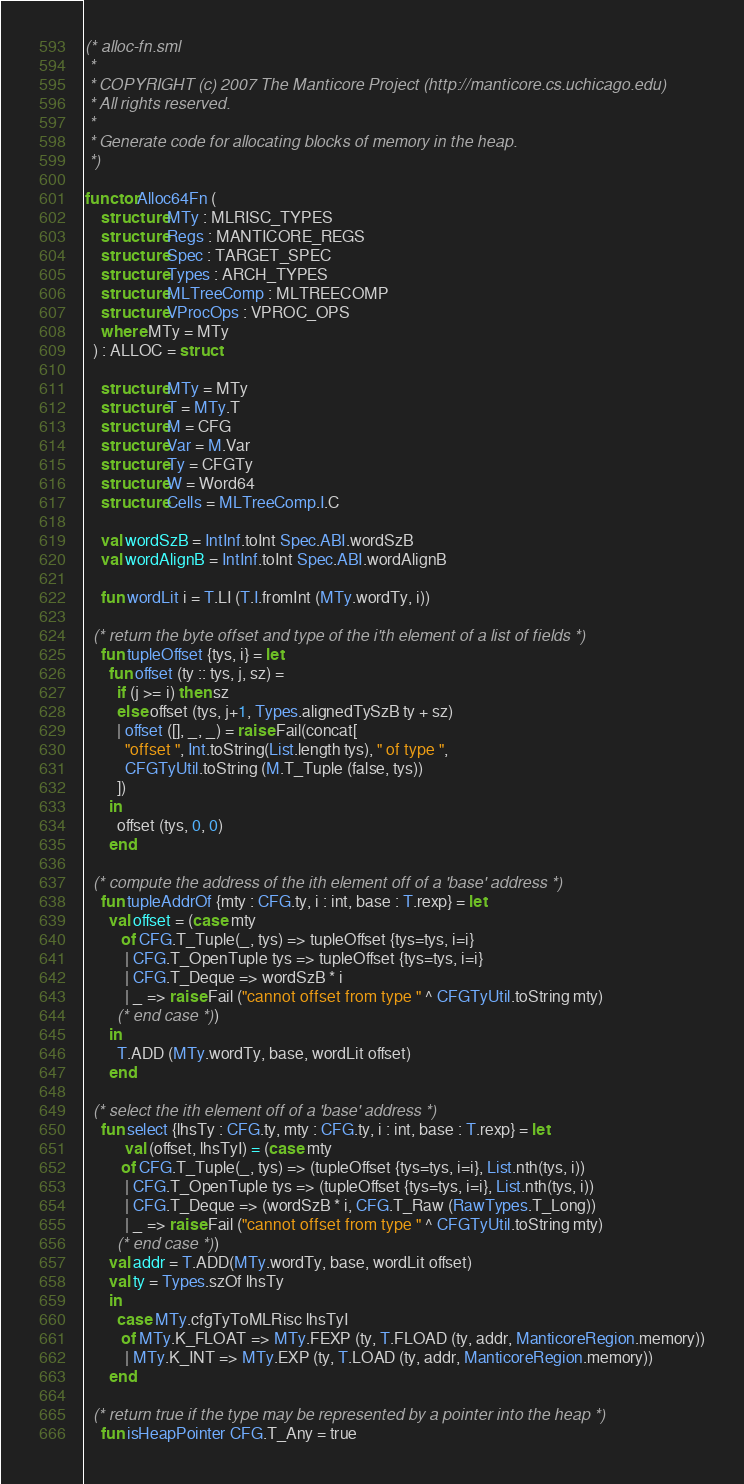<code> <loc_0><loc_0><loc_500><loc_500><_SML_>(* alloc-fn.sml
 *
 * COPYRIGHT (c) 2007 The Manticore Project (http://manticore.cs.uchicago.edu)
 * All rights reserved.
 *
 * Generate code for allocating blocks of memory in the heap.
 *)

functor Alloc64Fn (
    structure MTy : MLRISC_TYPES
    structure Regs : MANTICORE_REGS
    structure Spec : TARGET_SPEC
    structure Types : ARCH_TYPES
    structure MLTreeComp : MLTREECOMP
    structure VProcOps : VPROC_OPS
	where MTy = MTy
  ) : ALLOC = struct

    structure MTy = MTy
    structure T = MTy.T
    structure M = CFG
    structure Var = M.Var
    structure Ty = CFGTy
    structure W = Word64
    structure Cells = MLTreeComp.I.C

    val wordSzB = IntInf.toInt Spec.ABI.wordSzB
    val wordAlignB = IntInf.toInt Spec.ABI.wordAlignB

    fun wordLit i = T.LI (T.I.fromInt (MTy.wordTy, i))

  (* return the byte offset and type of the i'th element of a list of fields *)
    fun tupleOffset {tys, i} = let
	  fun offset (ty :: tys, j, sz) =
		if (j >= i) then sz
		else offset (tys, j+1, Types.alignedTySzB ty + sz)
	    | offset ([], _, _) = raise Fail(concat[
		  "offset ", Int.toString(List.length tys), " of type ",
		  CFGTyUtil.toString (M.T_Tuple (false, tys))
		])
	  in
	    offset (tys, 0, 0)
	  end

  (* compute the address of the ith element off of a 'base' address *)
    fun tupleAddrOf {mty : CFG.ty, i : int, base : T.rexp} = let
	  val offset = (case mty
		 of CFG.T_Tuple(_, tys) => tupleOffset {tys=tys, i=i}
		  | CFG.T_OpenTuple tys => tupleOffset {tys=tys, i=i}
		  | CFG.T_Deque => wordSzB * i
		  | _ => raise Fail ("cannot offset from type " ^ CFGTyUtil.toString mty)
		(* end case *))
	  in
	    T.ADD (MTy.wordTy, base, wordLit offset)
	  end

  (* select the ith element off of a 'base' address *)
    fun select {lhsTy : CFG.ty, mty : CFG.ty, i : int, base : T.rexp} = let
          val (offset, lhsTyI) = (case mty
		 of CFG.T_Tuple(_, tys) => (tupleOffset {tys=tys, i=i}, List.nth(tys, i))
		  | CFG.T_OpenTuple tys => (tupleOffset {tys=tys, i=i}, List.nth(tys, i))
		  | CFG.T_Deque => (wordSzB * i, CFG.T_Raw (RawTypes.T_Long))
		  | _ => raise Fail ("cannot offset from type " ^ CFGTyUtil.toString mty)
		(* end case *))
	  val addr = T.ADD(MTy.wordTy, base, wordLit offset)
	  val ty = Types.szOf lhsTy
	  in
	    case MTy.cfgTyToMLRisc lhsTyI
	     of MTy.K_FLOAT => MTy.FEXP (ty, T.FLOAD (ty, addr, ManticoreRegion.memory))
	      | MTy.K_INT => MTy.EXP (ty, T.LOAD (ty, addr, ManticoreRegion.memory))
	  end

  (* return true if the type may be represented by a pointer into the heap *)
    fun isHeapPointer CFG.T_Any = true</code> 